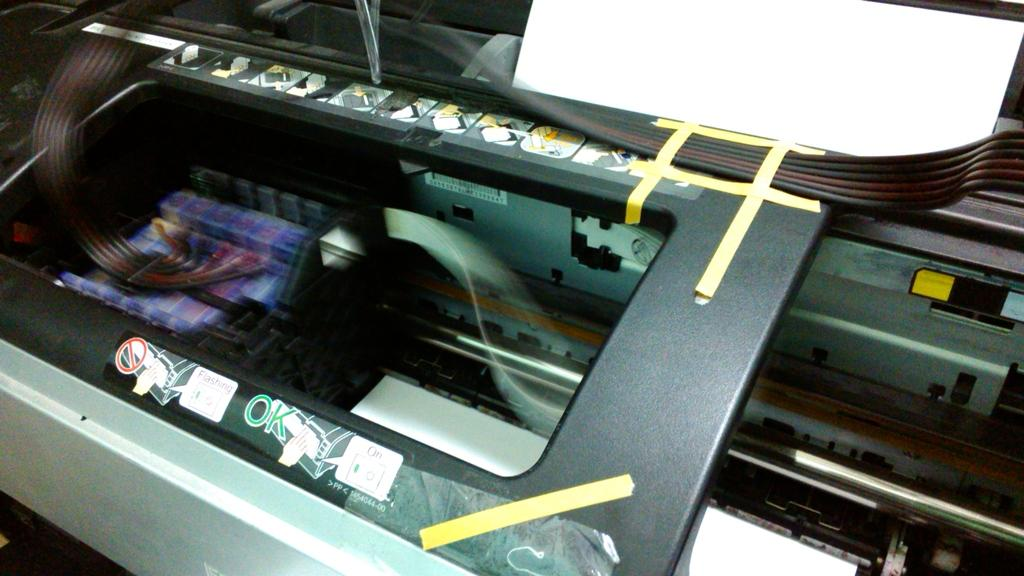What is the main object in the image? There is a machine in the image. What can be seen on the machine? There is text on the machine and plaster stuck on it. Is there any additional item on the machine? Yes, there is a paper in the top right corner of the machine. How many pets are sitting on the machine in the image? There are no pets present in the image. What type of kettle is used to balance the machine in the image? There is no kettle or balancing act depicted in the image; it only shows a machine with text, plaster, and a paper. 